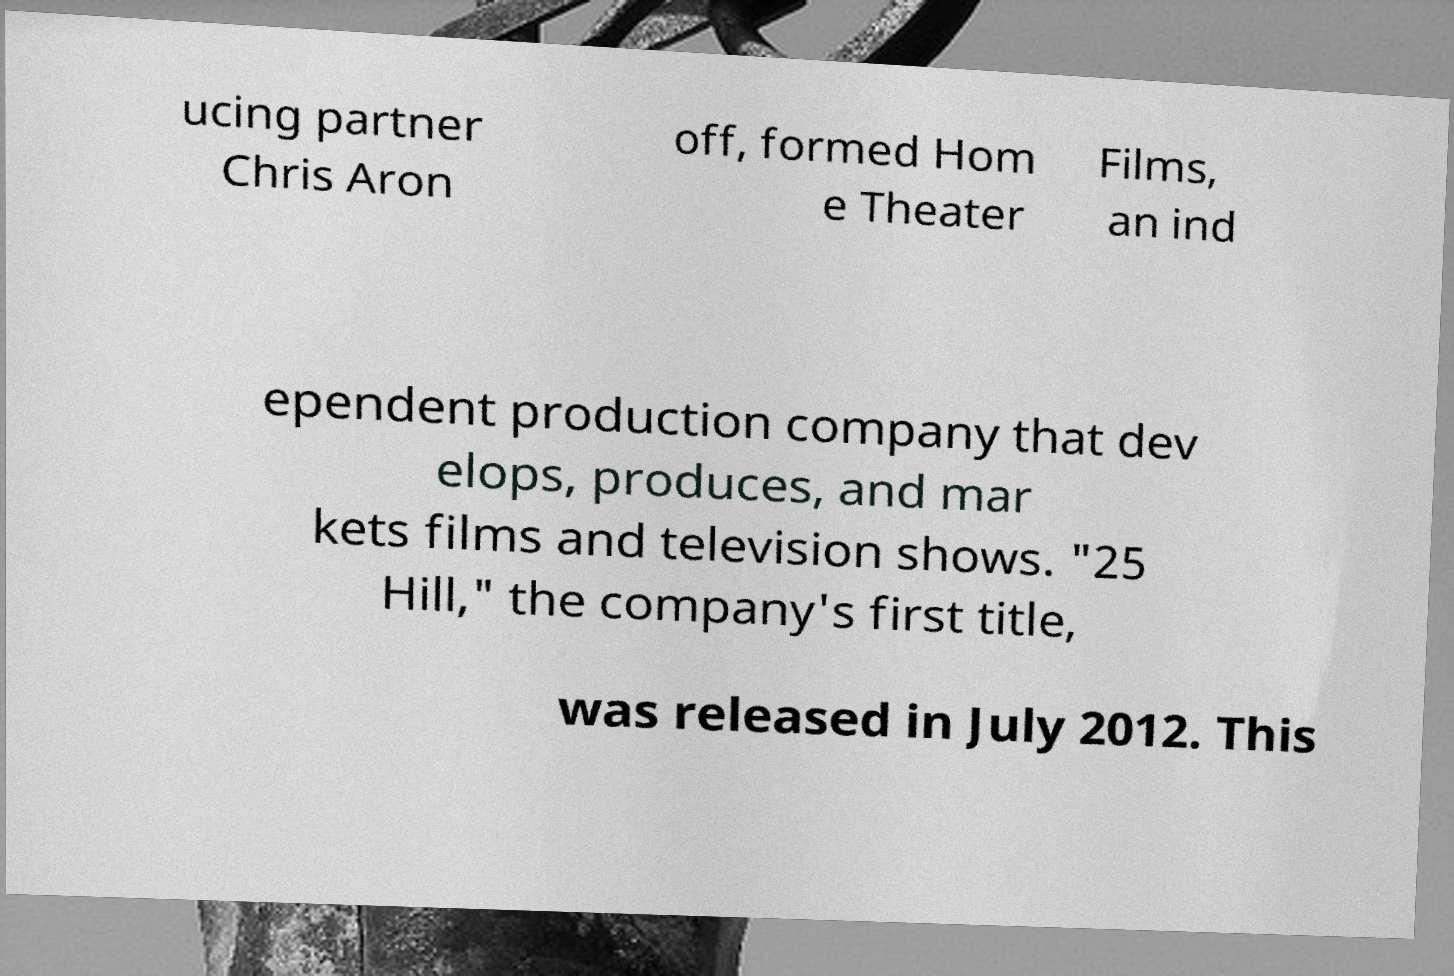Can you accurately transcribe the text from the provided image for me? ucing partner Chris Aron off, formed Hom e Theater Films, an ind ependent production company that dev elops, produces, and mar kets films and television shows. "25 Hill," the company's first title, was released in July 2012. This 